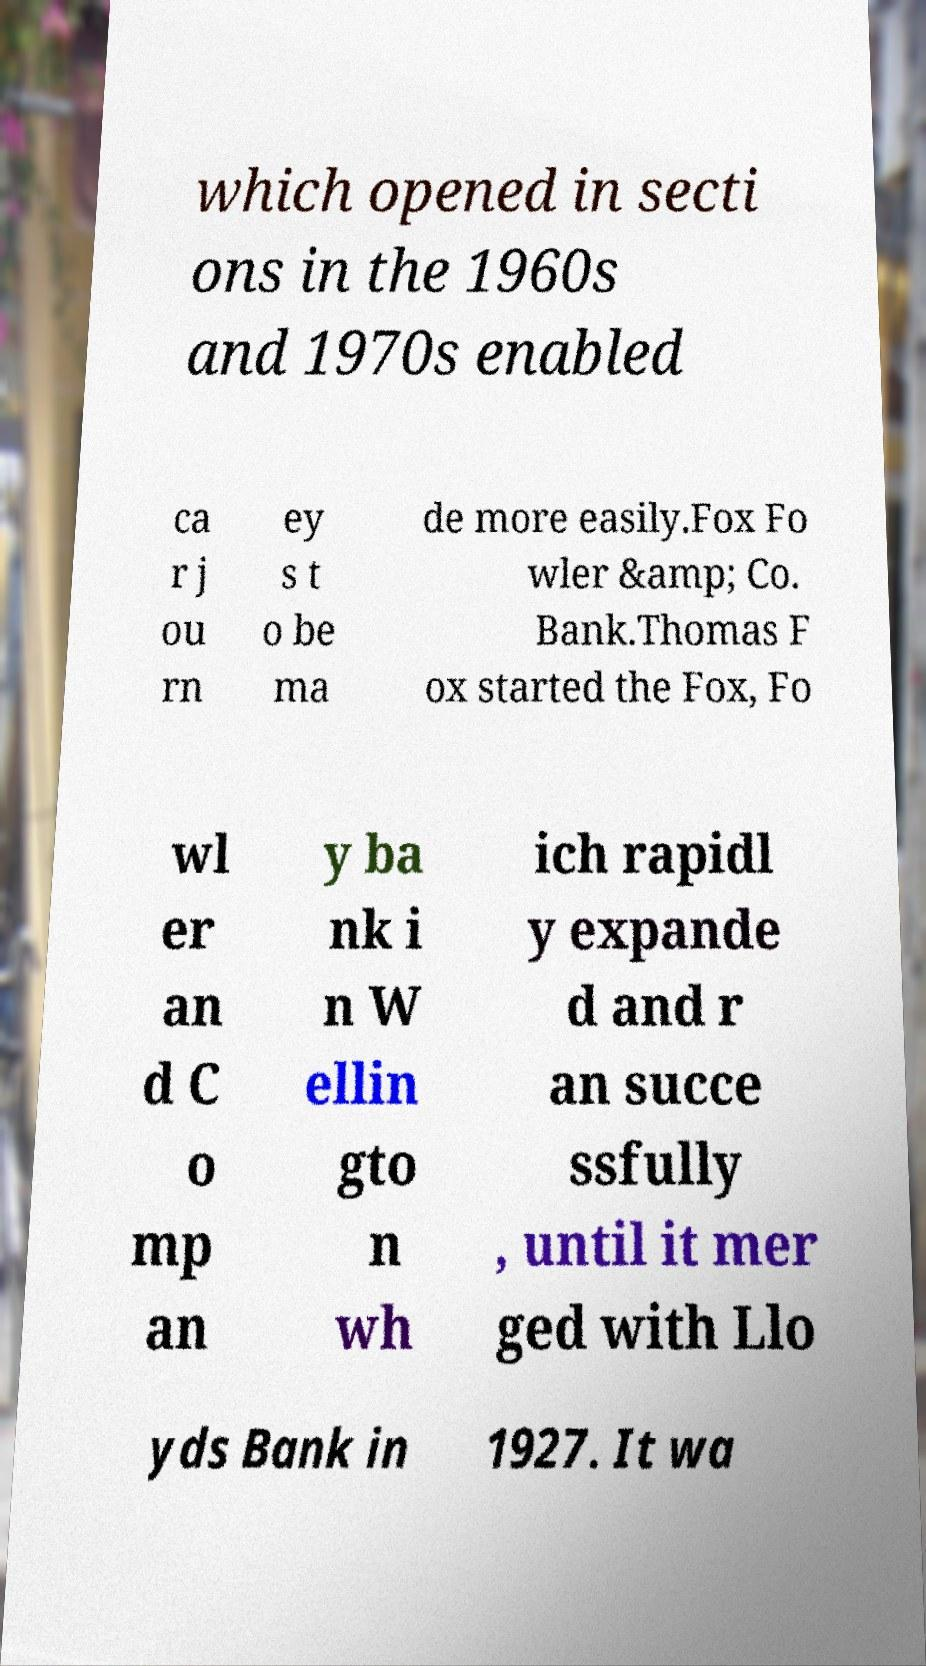Could you extract and type out the text from this image? which opened in secti ons in the 1960s and 1970s enabled ca r j ou rn ey s t o be ma de more easily.Fox Fo wler &amp; Co. Bank.Thomas F ox started the Fox, Fo wl er an d C o mp an y ba nk i n W ellin gto n wh ich rapidl y expande d and r an succe ssfully , until it mer ged with Llo yds Bank in 1927. It wa 